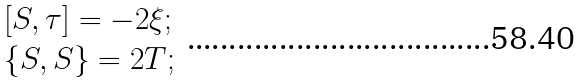<formula> <loc_0><loc_0><loc_500><loc_500>\begin{array} { l } \, \left [ S , \tau \right ] = - 2 \xi ; \\ \, \left \{ S , S \right \} = 2 T ; \end{array}</formula> 